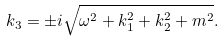Convert formula to latex. <formula><loc_0><loc_0><loc_500><loc_500>k _ { 3 } = \pm i \sqrt { \omega ^ { 2 } + k _ { 1 } ^ { 2 } + k _ { 2 } ^ { 2 } + m ^ { 2 } } .</formula> 